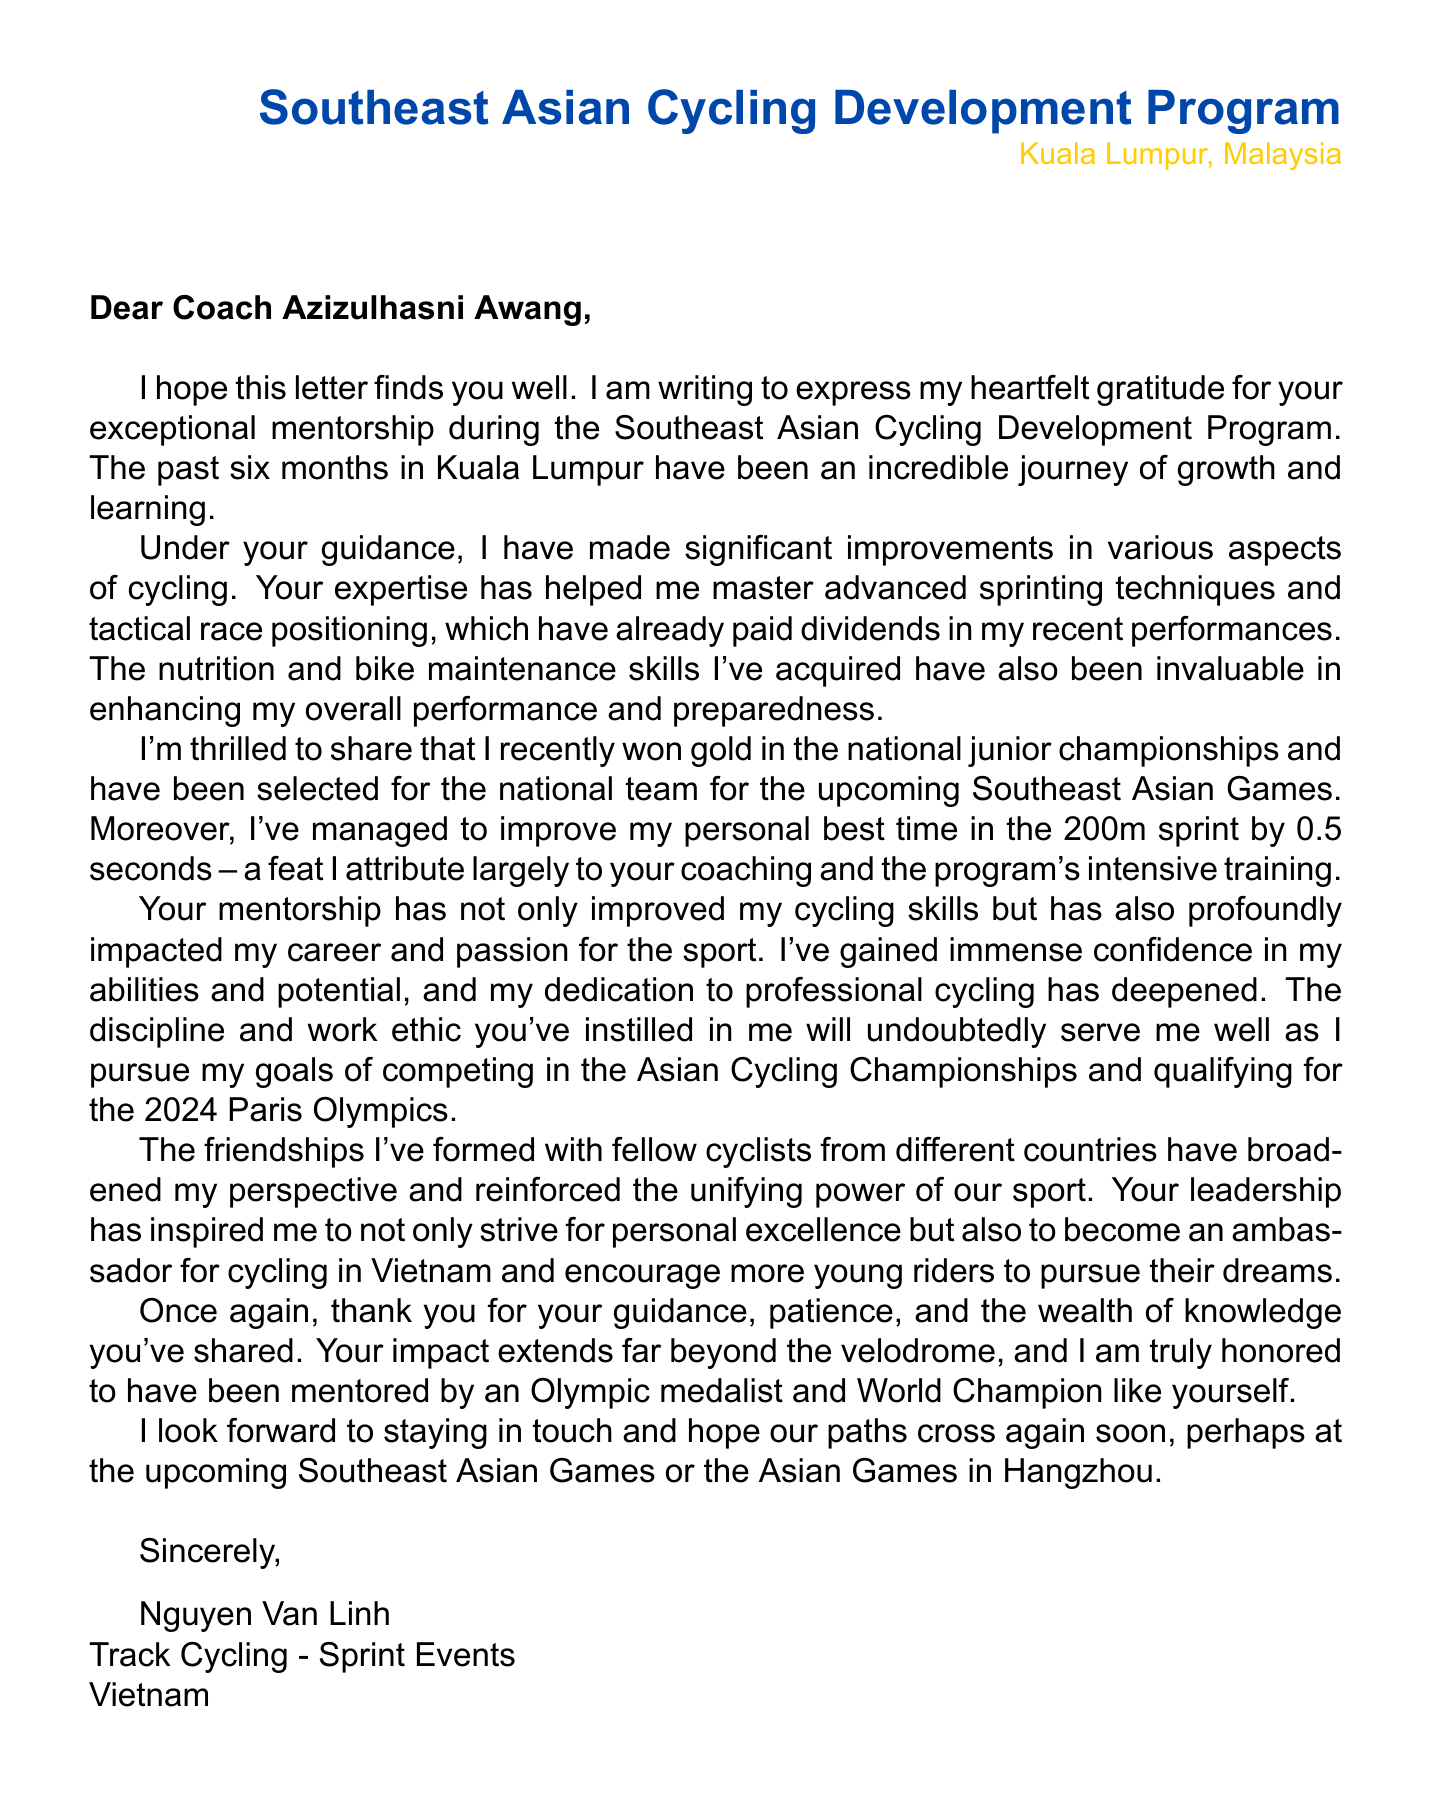What is the name of the mentor? The mentor's name is stated in the salutation of the letter as Azizulhasni Awang.
Answer: Azizulhasni Awang What program did Nguyen Van Linh participate in? The program is mentioned in the introduction of the letter as the Southeast Asian Cycling Development Program.
Answer: Southeast Asian Cycling Development Program How long did the program last? The duration of the program is specified in the document as 6 months.
Answer: 6 months What medal did the mentor win at the 2020 Olympics? The letter includes this information as the mentor won a silver medal at the 2020 Olympics.
Answer: Silver What personal achievement did Nguyen Van Linh mention? One achievement highlighted in the letter is winning gold in the national junior championships.
Answer: Gold in national junior championships What is one of Nguyen Van Linh's future goals? The letter states that Nguyen Van Linh aims to qualify for the 2024 Paris Olympics as a future goal.
Answer: Qualify for 2024 Paris Olympics What skill related to nutrition was learned during the program? The document highlights that the mentee learned about nutrition for endurance cycling.
Answer: Nutrition for endurance cycling What impact did the mentorship have on Nguyen Van Linh's confidence? The document states that he gained immense confidence in his abilities and potential due to the mentorship.
Answer: Gained confidence What is one challenge mentioned regarding cycling in the region? The letter refers to limited cycling infrastructure as one of the challenges faced.
Answer: Limited cycling infrastructure 